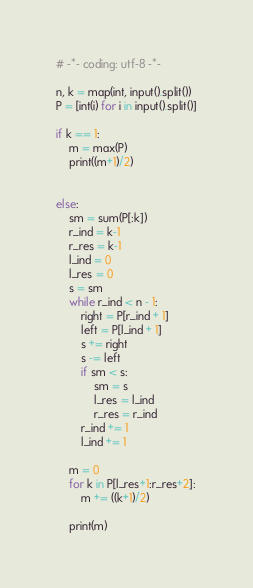<code> <loc_0><loc_0><loc_500><loc_500><_Python_># -*- coding: utf-8 -*-

n, k = map(int, input().split())
P = [int(i) for i in input().split()]

if k == 1:
    m = max(P)
    print((m+1)/2)


else:
    sm = sum(P[:k])
    r_ind = k-1
    r_res = k-1
    l_ind = 0
    l_res = 0
    s = sm
    while r_ind < n - 1:
        right = P[r_ind + 1]
        left = P[l_ind + 1]
        s += right
        s -= left
        if sm < s:
            sm = s
            l_res = l_ind
            r_res = r_ind
        r_ind += 1
        l_ind += 1

    m = 0
    for k in P[l_res+1:r_res+2]:
        m += ((k+1)/2)

    print(m)</code> 